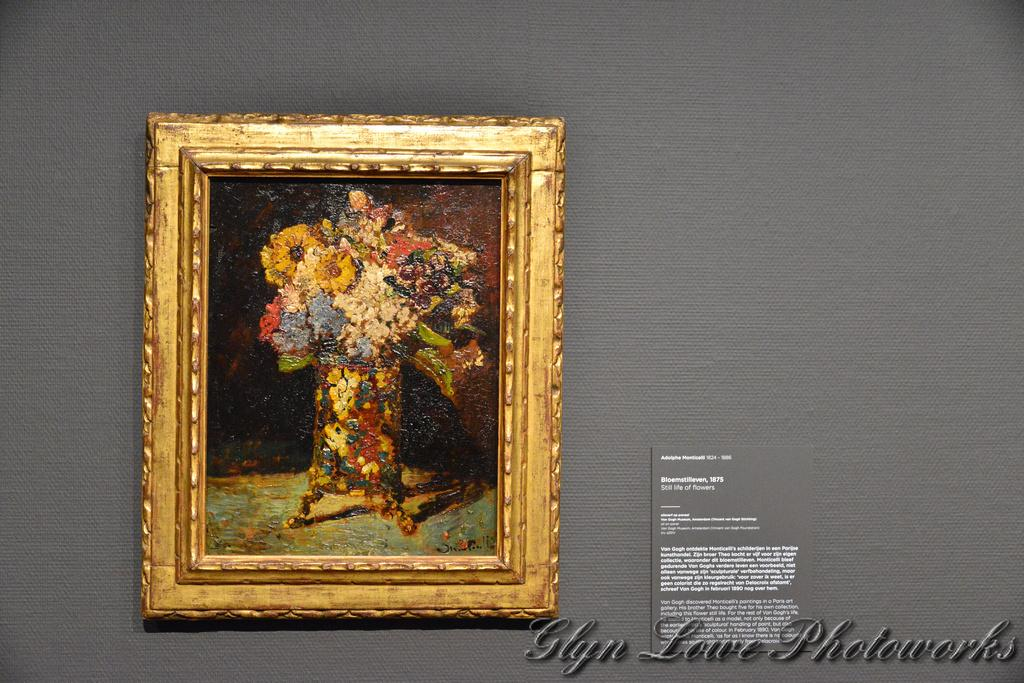What is the color of the wall in the image? The wall in the image is grey. What objects are attached to the wall? There is a photo frame and a board on the wall. Is there any indication that the image has been reproduced or copied? The image has a watermark, which may suggest that it has been reproduced or copied. What type of playground equipment can be seen in the image? There is no playground equipment present in the image; it features a grey wall with a photo frame and a board. 